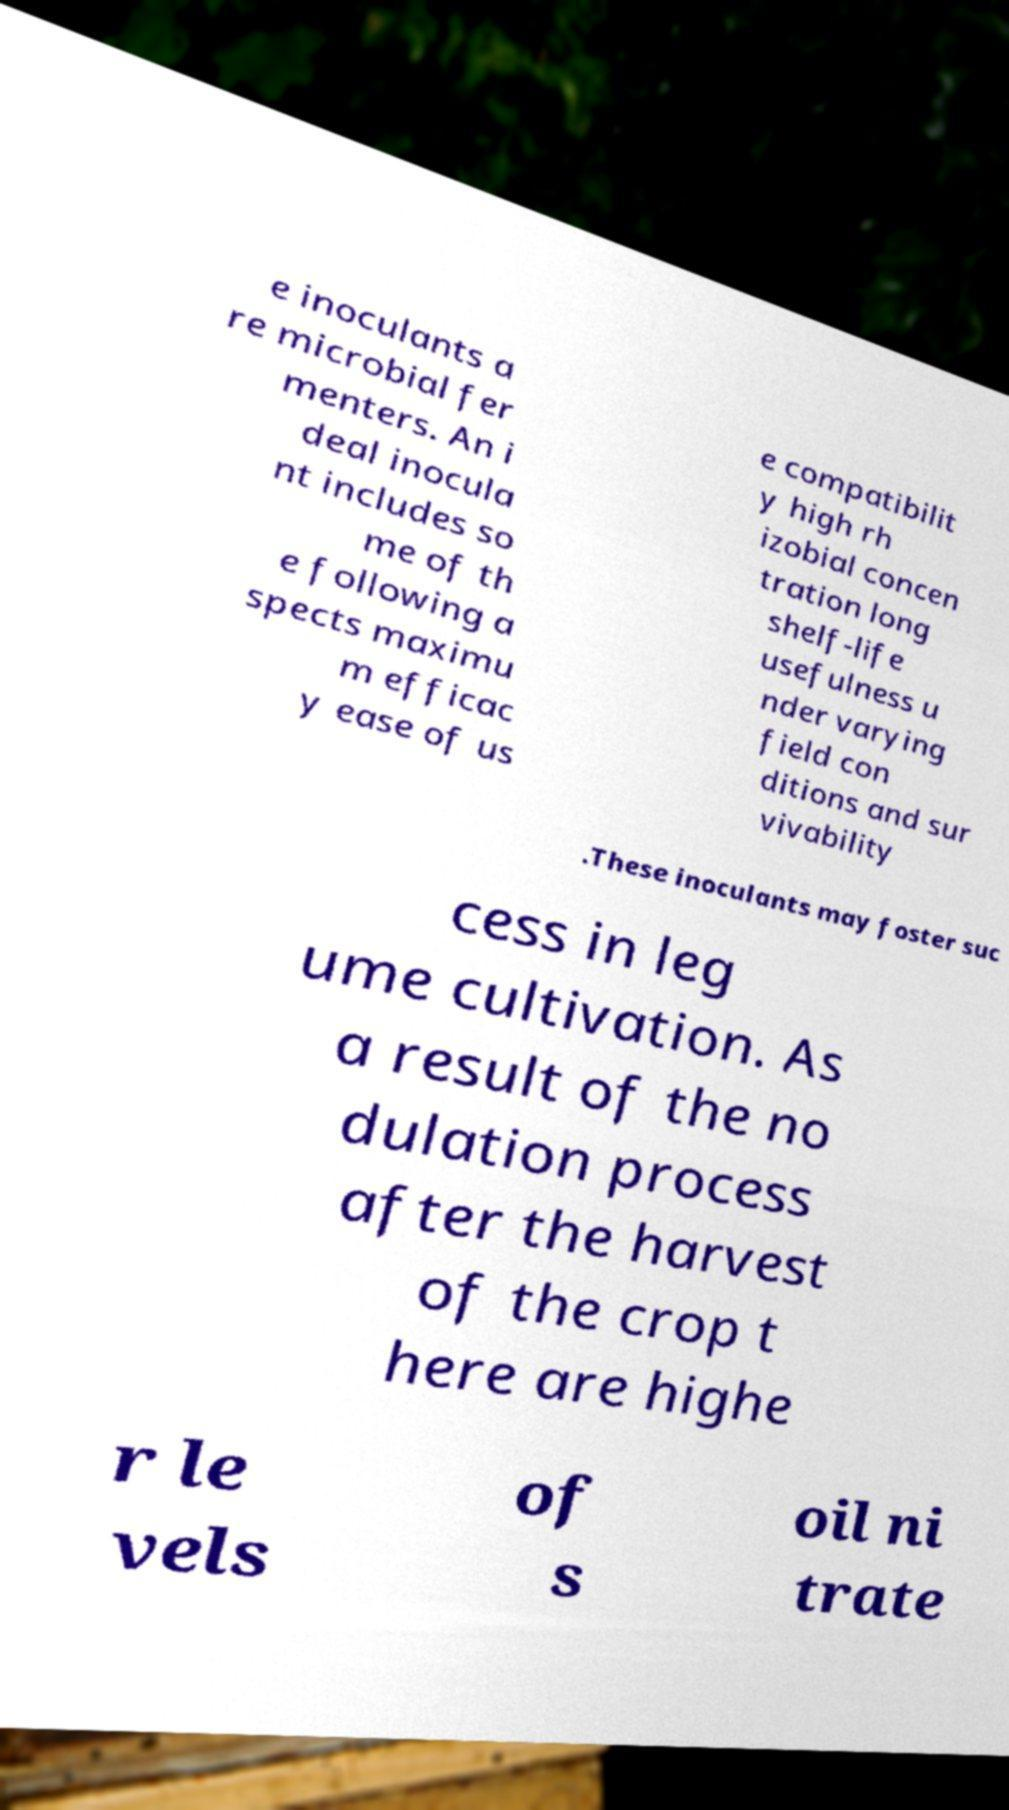There's text embedded in this image that I need extracted. Can you transcribe it verbatim? e inoculants a re microbial fer menters. An i deal inocula nt includes so me of th e following a spects maximu m efficac y ease of us e compatibilit y high rh izobial concen tration long shelf-life usefulness u nder varying field con ditions and sur vivability .These inoculants may foster suc cess in leg ume cultivation. As a result of the no dulation process after the harvest of the crop t here are highe r le vels of s oil ni trate 